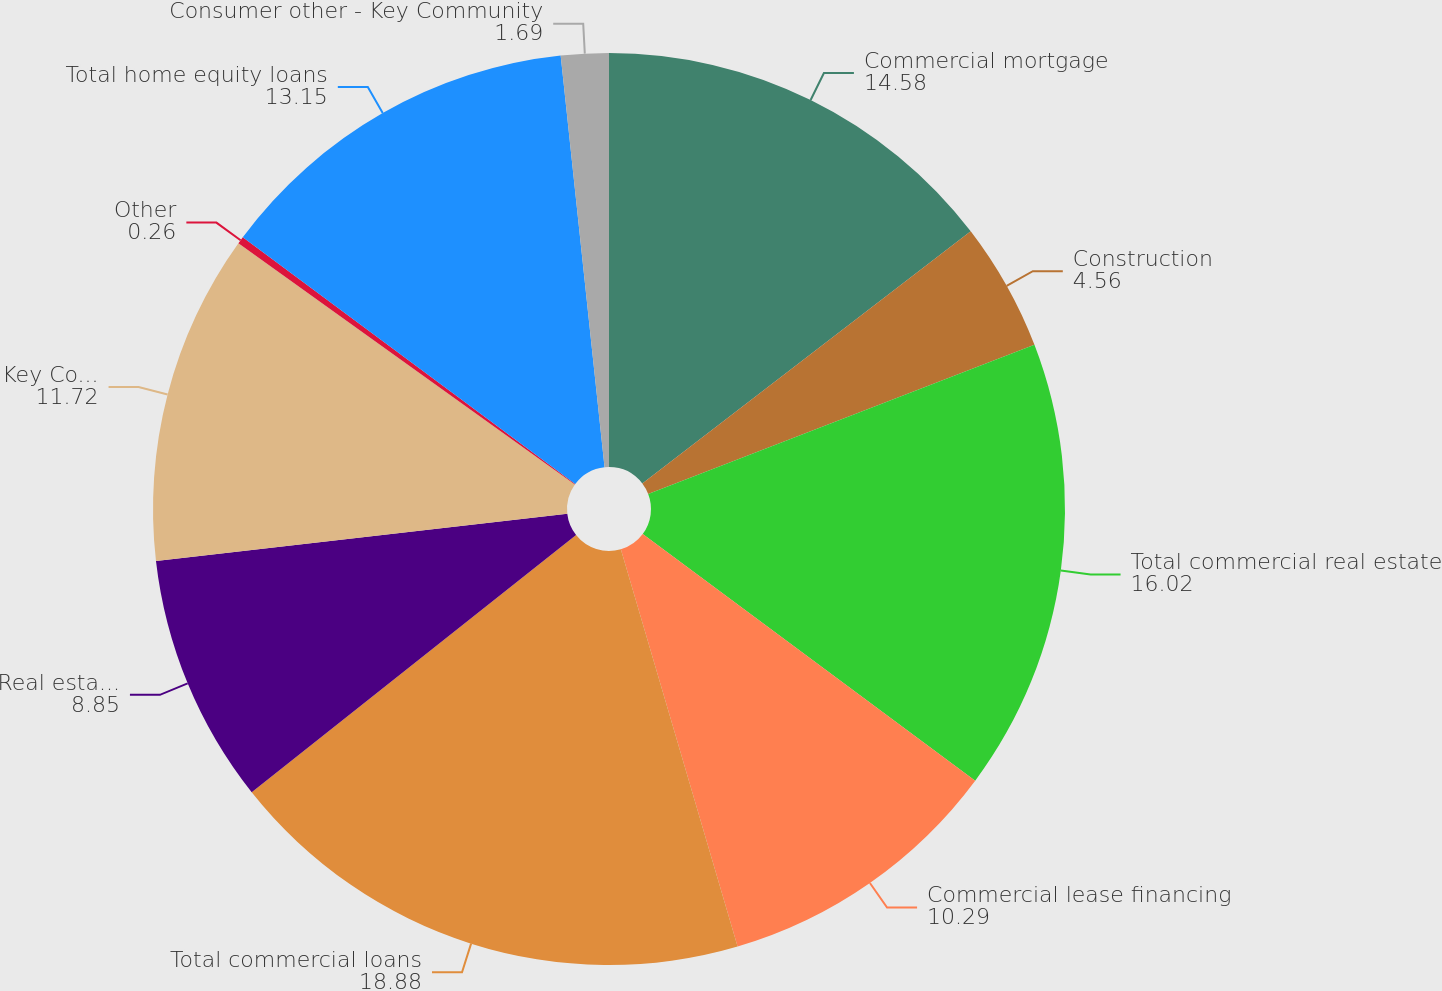Convert chart. <chart><loc_0><loc_0><loc_500><loc_500><pie_chart><fcel>Commercial mortgage<fcel>Construction<fcel>Total commercial real estate<fcel>Commercial lease financing<fcel>Total commercial loans<fcel>Real estate - residential<fcel>Key Community Bank<fcel>Other<fcel>Total home equity loans<fcel>Consumer other - Key Community<nl><fcel>14.58%<fcel>4.56%<fcel>16.02%<fcel>10.29%<fcel>18.88%<fcel>8.85%<fcel>11.72%<fcel>0.26%<fcel>13.15%<fcel>1.69%<nl></chart> 